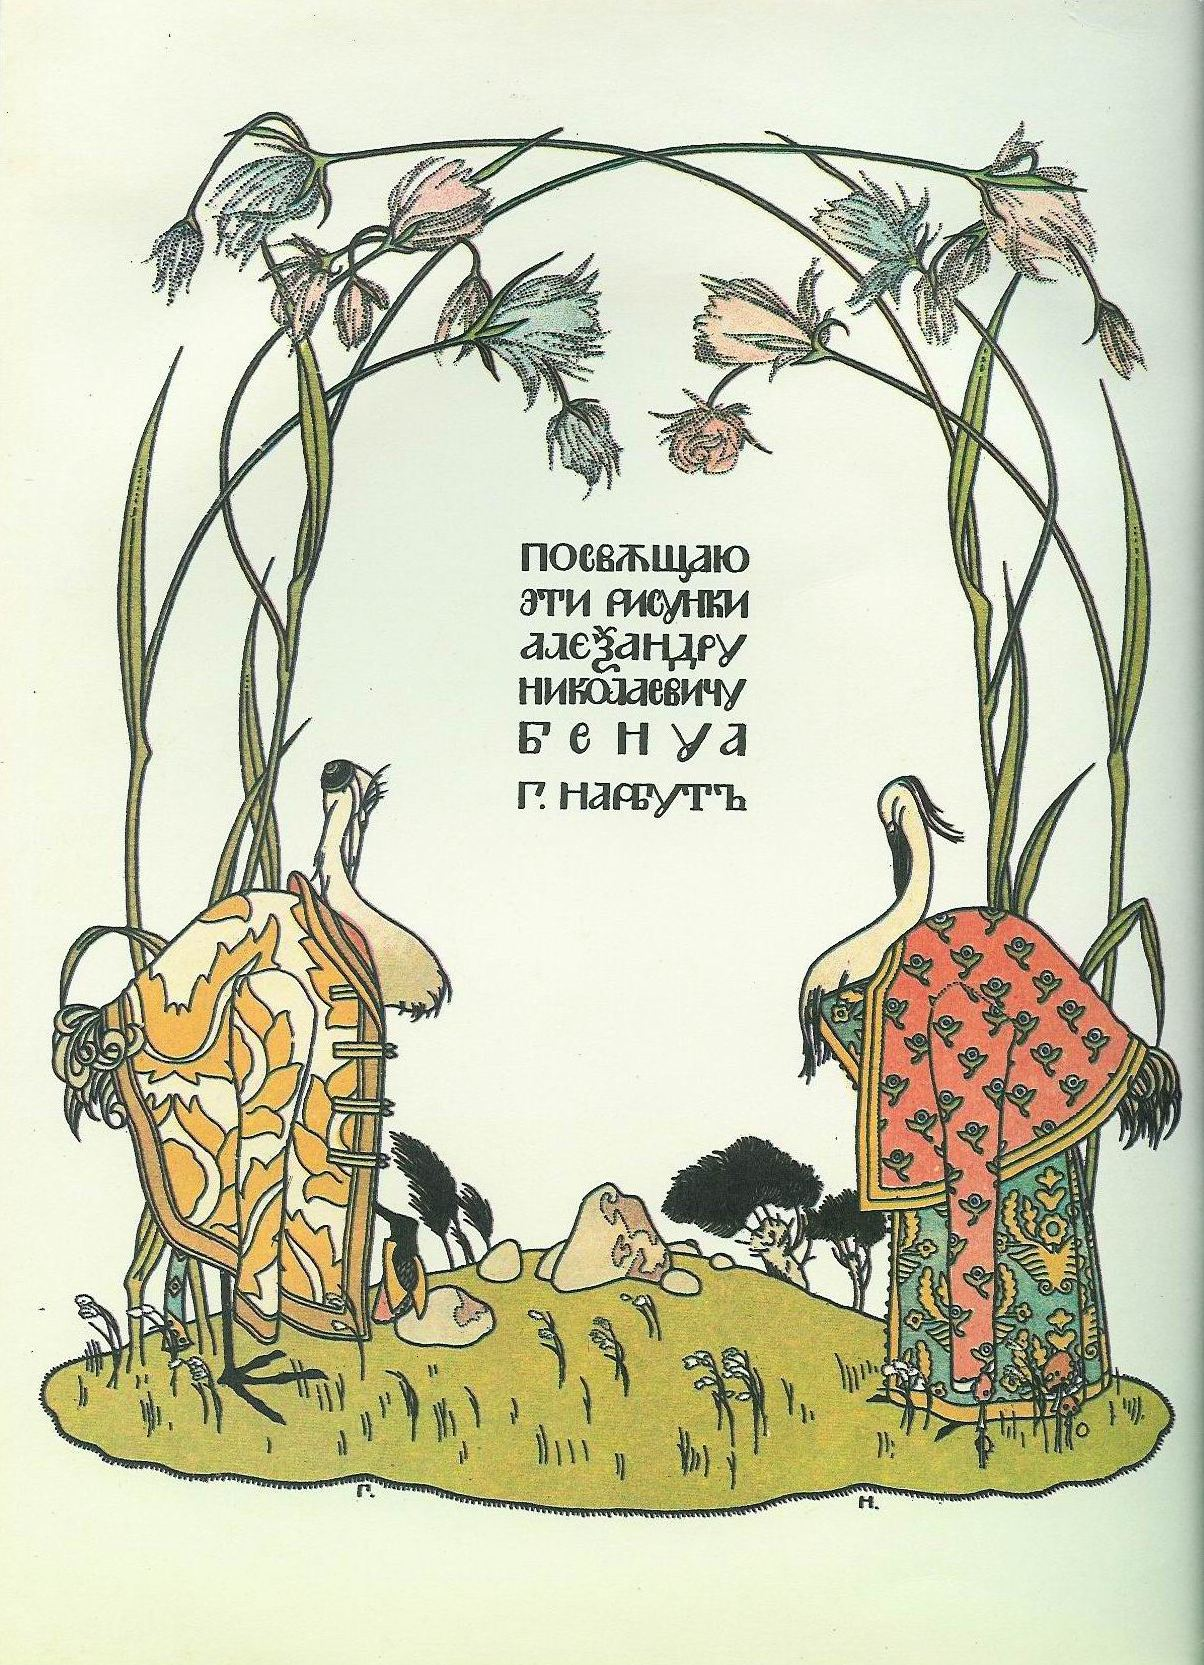If you were to set this scene in a modern context, what changes would you make? Setting this scene in a modern context, I would blend contemporary elements with traditional motifs to create a fusion of the old and new. The houses could be reimagined as modern eco-friendly homes, incorporating sustainable design and technology while maintaining the intricate patterns reminiscent of folk art. The storks might be depicted wearing contemporary clothing with folk-inspired designs, bridging the cultural heritage with modern fashion. The archway of green stems and flowers could be part of an urban garden project, emphasizing the harmony between nature and modern life. The text in the middle could be transformed into a digital display, perhaps an interactive element where viewers can read stories or dedications through augmented reality. This blend of the traditional and modern would create a rich, imaginative scene that pays homage to cultural roots while embracing contemporary innovation. What kind of emotions do you think the artist intended to evoke with this image? The artist likely intended to evoke a sense of tranquility, enchantment, and nostalgia with this image. The serene interplay of natural elements, the delicate and intricate designs, and the whimsical presence of storks dressed in patterned garments all contribute to a feeling of peacefulness and wonder. The pale green background adds a soothing effect, while the intricate details invite viewers to lose themselves in the enchantment of the scene. The artwork stirs a deep connection to tradition and folklore, evoking a nostalgic appreciation for the beauty and simplicity of the past, while the harmonious composition of natural motifs and artistic designs leaves viewers with a sense of balance and serenity. If you could step into this image, what would you do first? If I could step into this image, I would first approach the beautifully adorned storks, Sir Featherington and Lady Plummewing, and ask them to share the stories and wisdom of the land. I would explore the intricately designed houses and admire the craftsmanship and artistic patterns up close. Then, I would wander through the magical garden, drawn by the lush archway of green stems and pink flowers, and take a moment to rest under its enchanting canopy, absorbing the tranquility and magic of the scene. The experience would be a journey into a fairy tale, filled with discoveries and moments of peaceful reflection amidst the natural beauty and artistic splendor. 